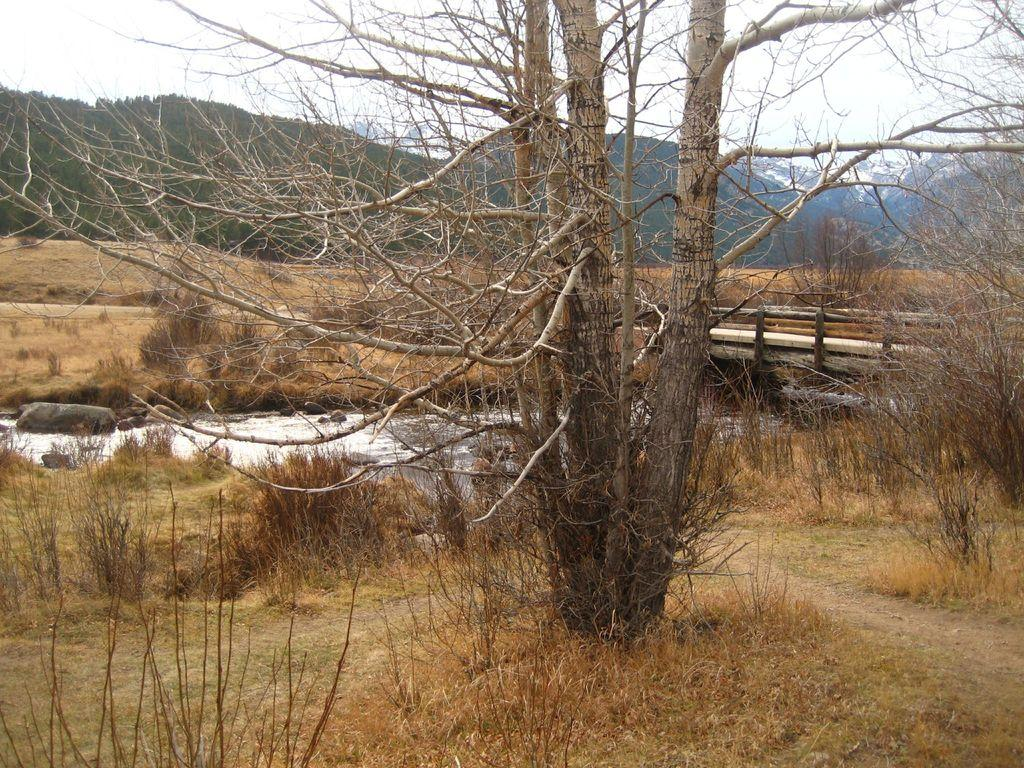What type of vegetation can be seen in the image? There are dry trees and grass visible in the image. What can be seen in the water in the image? There are stones visible in the water in the image. What type of structure is present in the image? There is a bridge in the image. What type of geographical feature is visible in the background of the image? There are mountains in the image. What is the color of the sky in the image? The sky appears to be white in color. Are there any tombstones or gravestones visible in the image? There are no tombstones or gravestones present in the image. Can you see any bats flying around in the image? There are no bats visible in the image. 